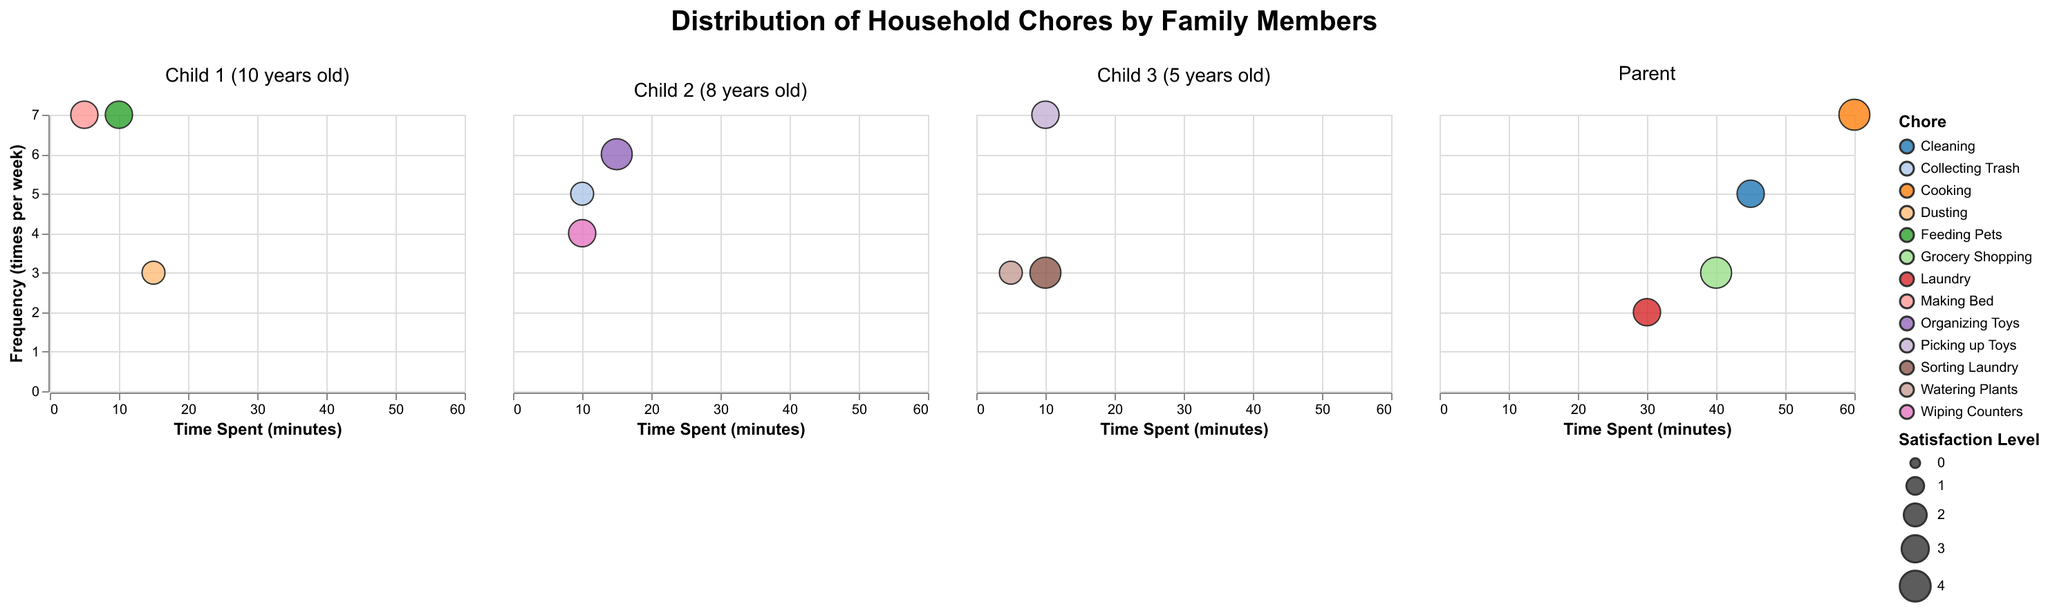What is the title of the plot? The title is located at the top center of the plot. It reads "Distribution of Household Chores by Family Members".
Answer: Distribution of Household Chores by Family Members Which chore takes the most time for the parent? To find this, look at the "Parent" subplot and check the bubble furthest to the right on the "Time Spent (minutes)" axis. That's the bubble for "Cooking" at 60 minutes.
Answer: Cooking How often does Child 1 (10 years old) feed pets per week? Look at the "Child 1 (10 years old)" subplot and identify the bubble for "Feeding Pets". Check the y-axis value for this bubble, which shows a frequency of 7 times per week.
Answer: 7 times What is the satisfaction level for Child 2 (8 years old) when organizing toys? In the subplot for "Child 2 (8 years old)", find the bubble for "Organizing Toys" and check the size of the bubble. The legend shows it corresponds to a satisfaction level of 4.
Answer: 4 Which family member has the chore with the lowest satisfaction level? Compare the bubbles in all subplots for their size, the smallest one is "Dusting" for "Child 1 (10 years old)" and "Collecting Trash" for "Child 2 (8 years old)", both with a satisfaction level of 2.
Answer: Child 1 and Child 2 Who spends more time on chore: Parent cooking or Child 3 (5 years old) picking up toys? Compare the "Time Spent (minutes)" between the "Cooking" bubble in the "Parent" subplot (60 minutes) and the "Picking up Toys" bubble in the "Child 3 (5 years old)" subplot (10 minutes).
Answer: Parent Which chore is most frequently done by Child 2 (8 years old)? In the "Child 2 (8 years old)" subplot, find the bubble with the highest value on the "Frequency (times per week)" axis. This is "Organizing Toys" with a frequency of 6 times per week.
Answer: Organizing Toys What is the total time spent by the parent on chores per week? Sum the "Time Spent (minutes)" for each chore in the "Parent" subplot: Cooking (60) + Cleaning (45) + Laundry (30) + Grocery Shopping (40) = 175 minutes.
Answer: 175 minutes Which has a higher satisfaction level, Child 1 (10 years old) feeding pets or Child 3 (5 years old) watering plants? Compare the size of the bubbles in the respective subplots; "Feeding Pets" for "Child 1 (10 years old)" has a satisfaction level of 3, while "Watering Plants" for "Child 3 (5 years old)" has a satisfaction level of 2.
Answer: Child 1 (10 years old) feeding pets What's the average frequency of chores for Child 3 (5 years old)? Calculate the average of the frequencies for Child 3’s three chores: (7 picking up toys + 3 sorting laundry + 3 watering plants) / 3 = 13 / 3 ≈ 4.33.
Answer: 4.33 times per week 